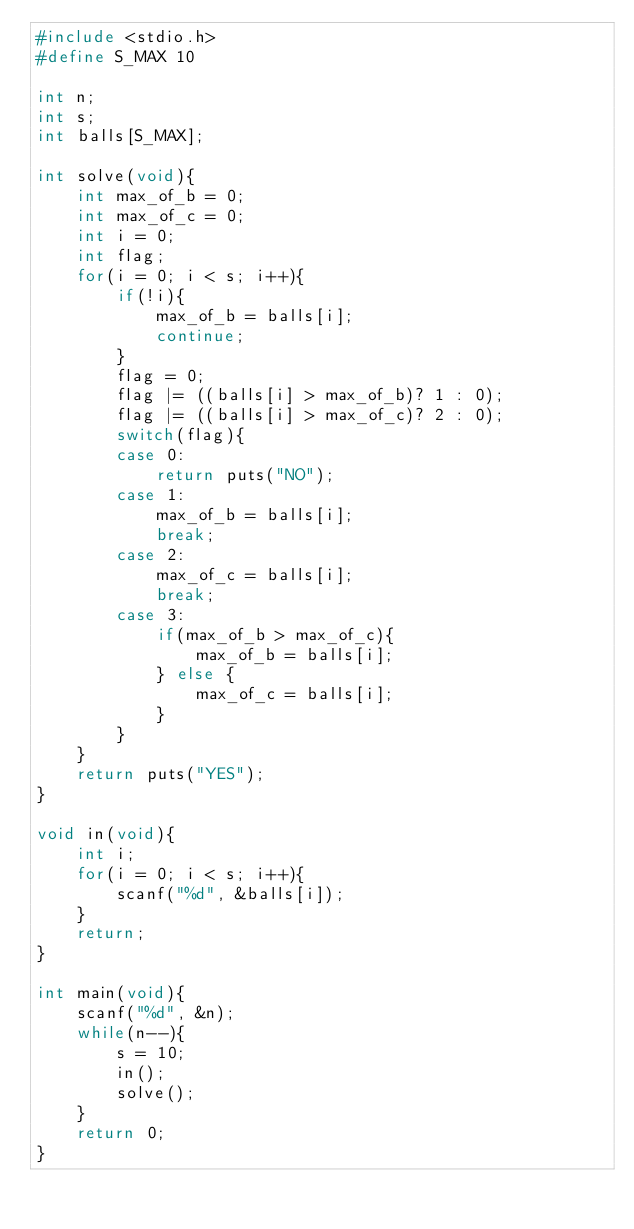Convert code to text. <code><loc_0><loc_0><loc_500><loc_500><_C_>#include <stdio.h>
#define S_MAX 10

int n;
int s;
int balls[S_MAX];

int solve(void){
	int max_of_b = 0;
	int max_of_c = 0;
	int i = 0;
	int flag;
	for(i = 0; i < s; i++){
		if(!i){
			max_of_b = balls[i];
			continue;
		}
		flag = 0;
		flag |= ((balls[i] > max_of_b)? 1 : 0);
		flag |= ((balls[i] > max_of_c)? 2 : 0);
		switch(flag){
		case 0:
			return puts("NO");
		case 1:
			max_of_b = balls[i];
			break;
		case 2:
			max_of_c = balls[i];
			break;
		case 3:
			if(max_of_b > max_of_c){
				max_of_b = balls[i];
			} else {
				max_of_c = balls[i];
			}
		}
	}
	return puts("YES");
}

void in(void){
	int i;
	for(i = 0; i < s; i++){
		scanf("%d", &balls[i]);
	}
	return;
}

int main(void){
	scanf("%d", &n);
	while(n--){
		s = 10;
		in();
		solve();
	}
	return 0;
}</code> 